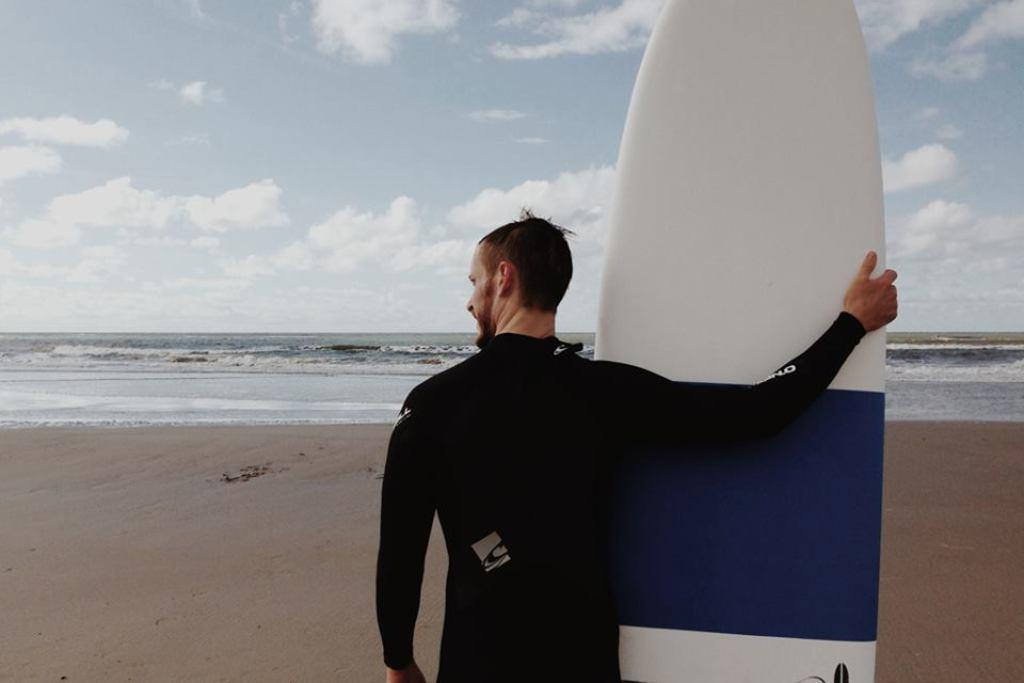What can be seen in the background of the image? The background of the image includes the sky with clouds. What is the weather like in the image? It appears to be a cloudy day. Where is the image set? The image is set at a beach. What is the man in the image holding? The man is holding a surfboard. What type of education does the range of mountains in the image provide? There are no mountains present in the image, so it is not possible to discuss the education they might provide. 